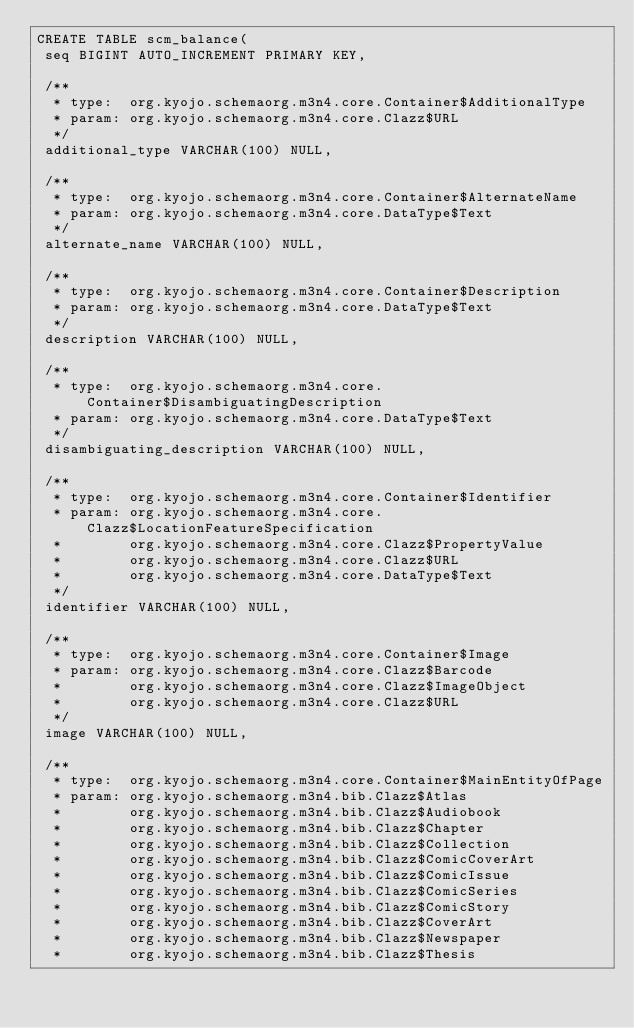<code> <loc_0><loc_0><loc_500><loc_500><_SQL_>CREATE TABLE scm_balance(
 seq BIGINT AUTO_INCREMENT PRIMARY KEY,

 /**
  * type:  org.kyojo.schemaorg.m3n4.core.Container$AdditionalType
  * param: org.kyojo.schemaorg.m3n4.core.Clazz$URL
  */
 additional_type VARCHAR(100) NULL,

 /**
  * type:  org.kyojo.schemaorg.m3n4.core.Container$AlternateName
  * param: org.kyojo.schemaorg.m3n4.core.DataType$Text
  */
 alternate_name VARCHAR(100) NULL,

 /**
  * type:  org.kyojo.schemaorg.m3n4.core.Container$Description
  * param: org.kyojo.schemaorg.m3n4.core.DataType$Text
  */
 description VARCHAR(100) NULL,

 /**
  * type:  org.kyojo.schemaorg.m3n4.core.Container$DisambiguatingDescription
  * param: org.kyojo.schemaorg.m3n4.core.DataType$Text
  */
 disambiguating_description VARCHAR(100) NULL,

 /**
  * type:  org.kyojo.schemaorg.m3n4.core.Container$Identifier
  * param: org.kyojo.schemaorg.m3n4.core.Clazz$LocationFeatureSpecification
  *        org.kyojo.schemaorg.m3n4.core.Clazz$PropertyValue
  *        org.kyojo.schemaorg.m3n4.core.Clazz$URL
  *        org.kyojo.schemaorg.m3n4.core.DataType$Text
  */
 identifier VARCHAR(100) NULL,

 /**
  * type:  org.kyojo.schemaorg.m3n4.core.Container$Image
  * param: org.kyojo.schemaorg.m3n4.core.Clazz$Barcode
  *        org.kyojo.schemaorg.m3n4.core.Clazz$ImageObject
  *        org.kyojo.schemaorg.m3n4.core.Clazz$URL
  */
 image VARCHAR(100) NULL,

 /**
  * type:  org.kyojo.schemaorg.m3n4.core.Container$MainEntityOfPage
  * param: org.kyojo.schemaorg.m3n4.bib.Clazz$Atlas
  *        org.kyojo.schemaorg.m3n4.bib.Clazz$Audiobook
  *        org.kyojo.schemaorg.m3n4.bib.Clazz$Chapter
  *        org.kyojo.schemaorg.m3n4.bib.Clazz$Collection
  *        org.kyojo.schemaorg.m3n4.bib.Clazz$ComicCoverArt
  *        org.kyojo.schemaorg.m3n4.bib.Clazz$ComicIssue
  *        org.kyojo.schemaorg.m3n4.bib.Clazz$ComicSeries
  *        org.kyojo.schemaorg.m3n4.bib.Clazz$ComicStory
  *        org.kyojo.schemaorg.m3n4.bib.Clazz$CoverArt
  *        org.kyojo.schemaorg.m3n4.bib.Clazz$Newspaper
  *        org.kyojo.schemaorg.m3n4.bib.Clazz$Thesis</code> 